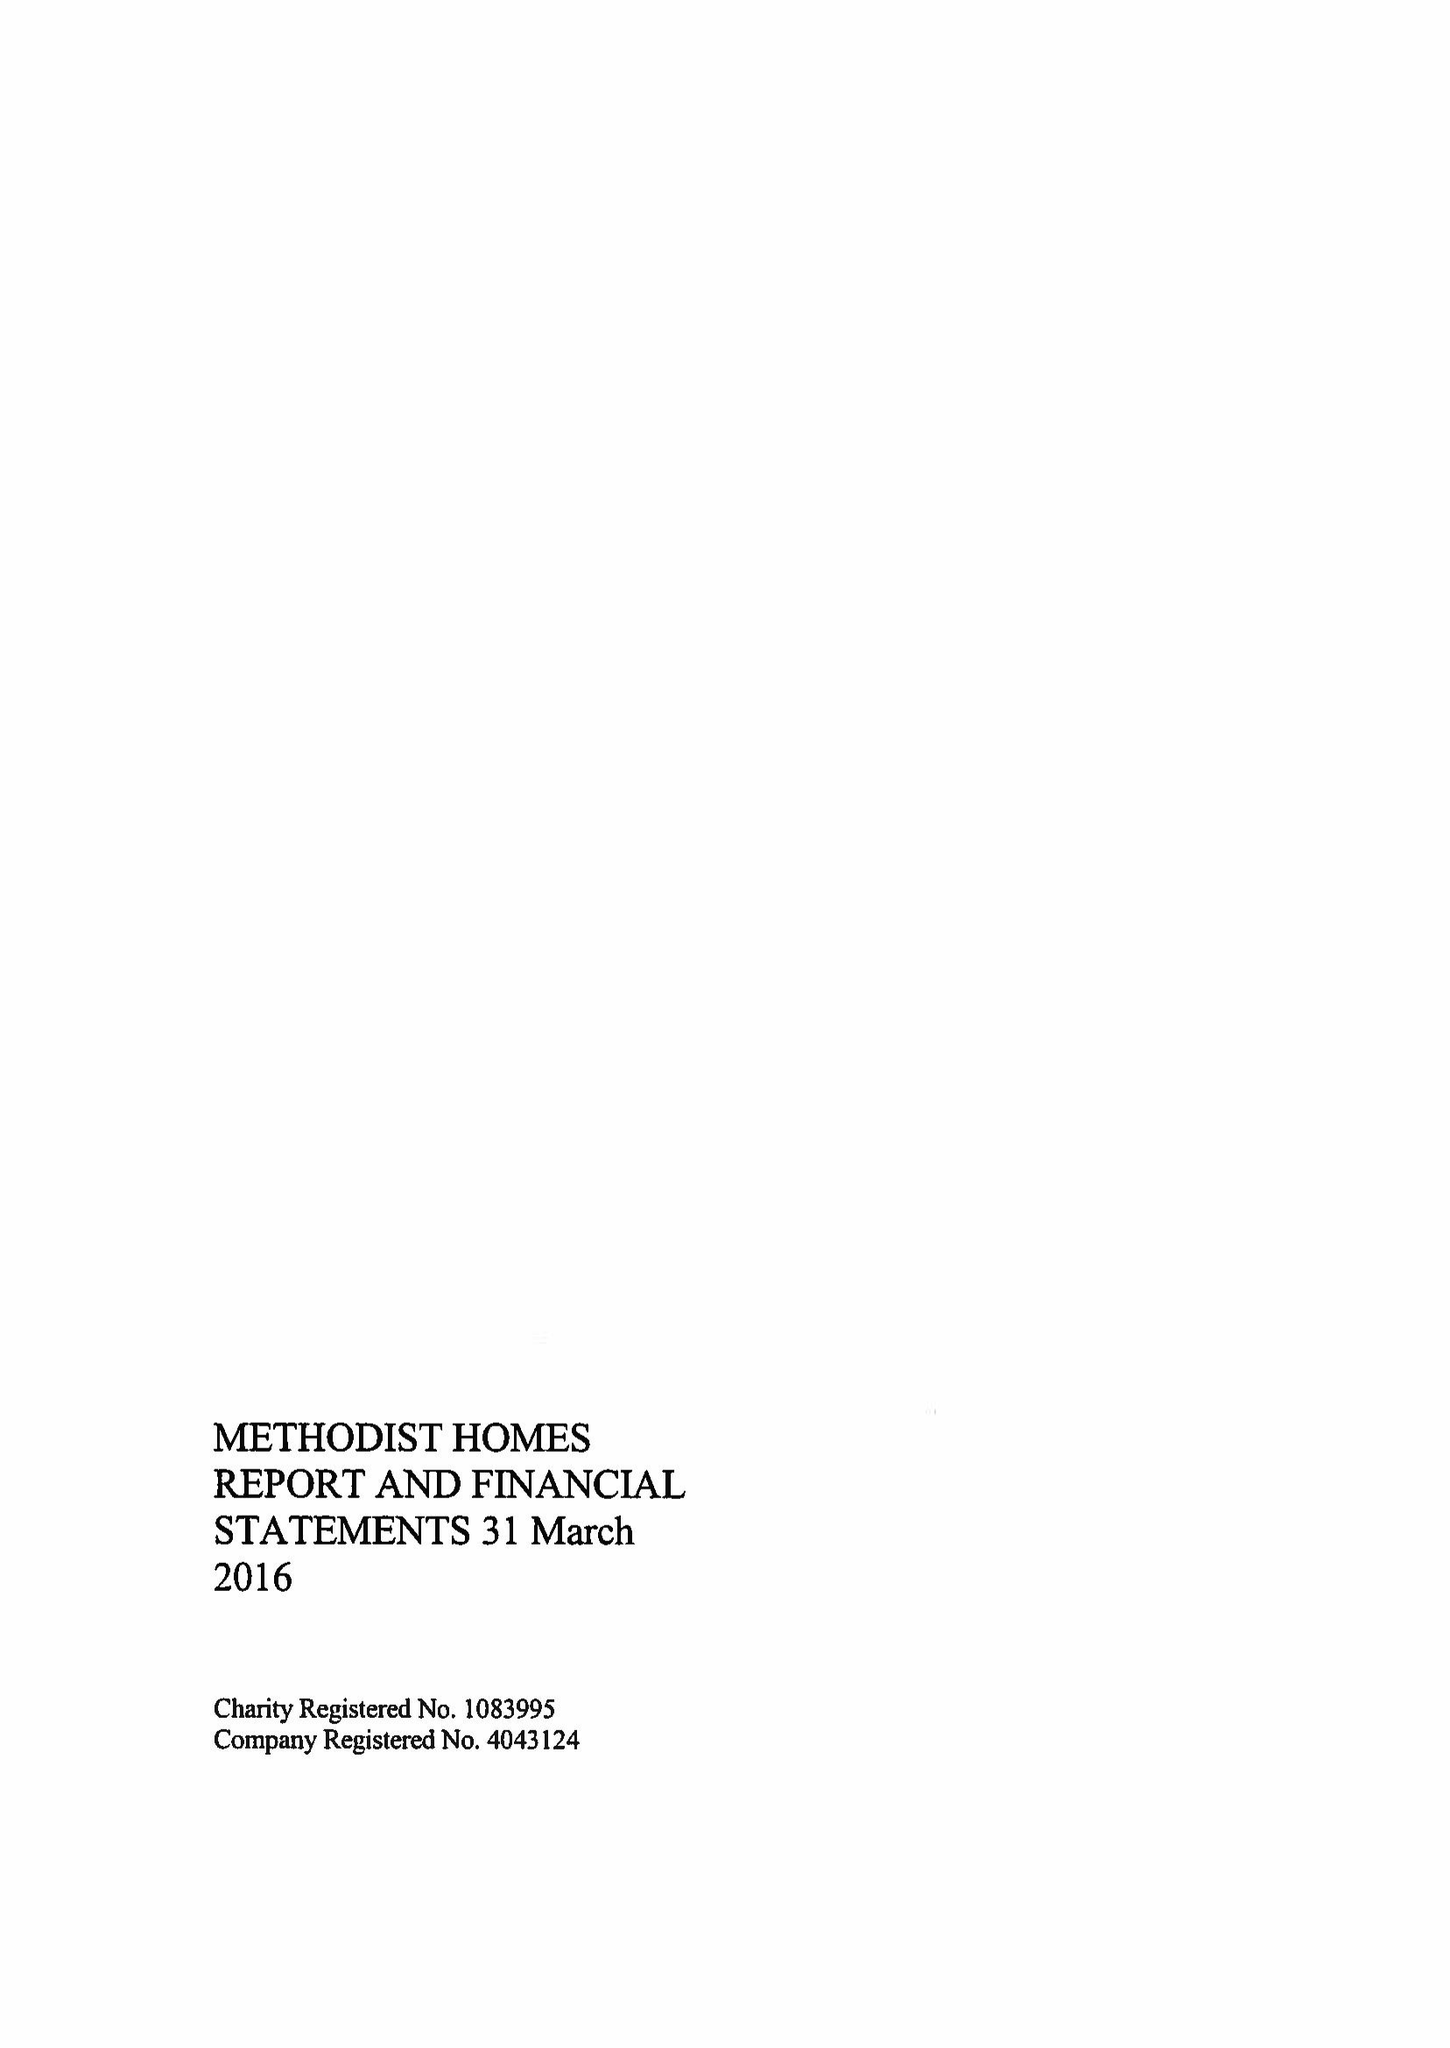What is the value for the report_date?
Answer the question using a single word or phrase. 2016-03-31 